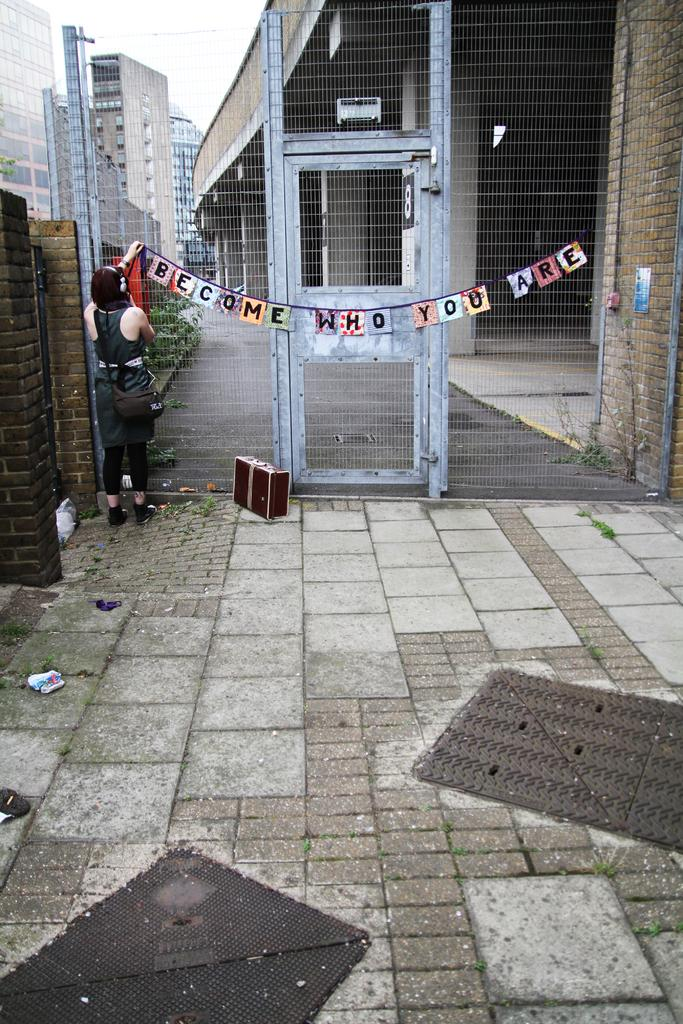<image>
Render a clear and concise summary of the photo. A sign hanging up that says welcome who you are 